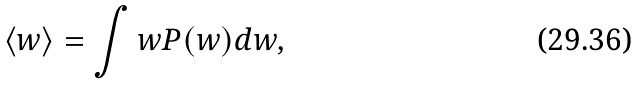<formula> <loc_0><loc_0><loc_500><loc_500>\langle w \rangle = \int w P ( w ) d w ,</formula> 